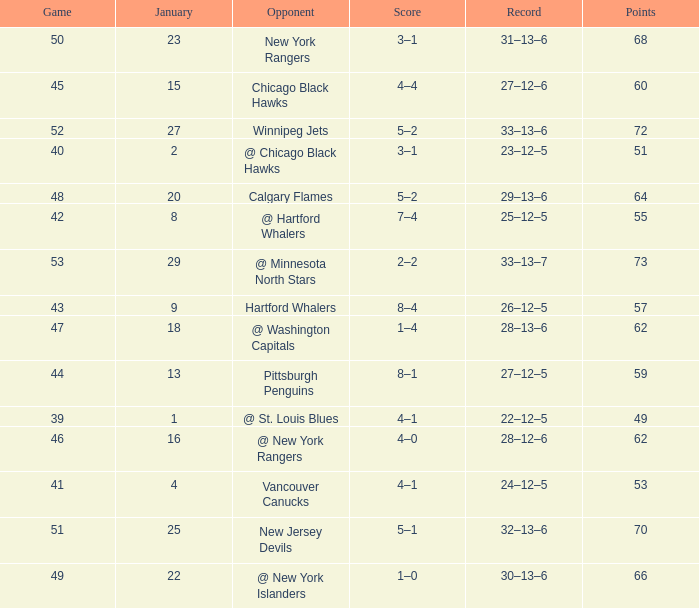Which Points is the lowest one that has a Score of 1–4, and a January smaller than 18? None. 